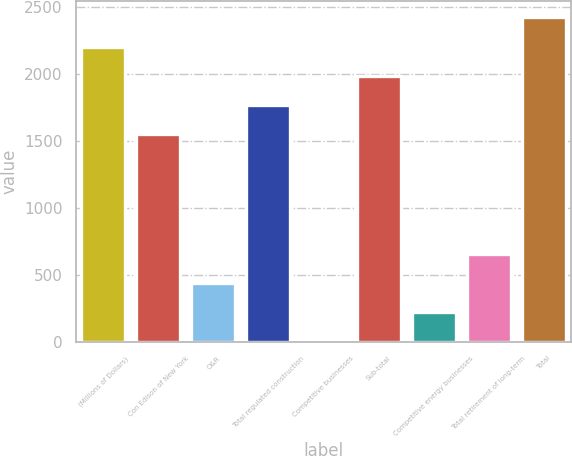<chart> <loc_0><loc_0><loc_500><loc_500><bar_chart><fcel>(Millions of Dollars)<fcel>Con Edison of New York<fcel>O&R<fcel>Total regulated construction<fcel>Competitive businesses<fcel>Sub-total<fcel>Competitive energy businesses<fcel>Total retirement of long-term<fcel>Total<nl><fcel>2201.3<fcel>1550<fcel>440.2<fcel>1767.1<fcel>6<fcel>1984.2<fcel>223.1<fcel>657.3<fcel>2418.4<nl></chart> 